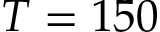Convert formula to latex. <formula><loc_0><loc_0><loc_500><loc_500>T = 1 5 0</formula> 